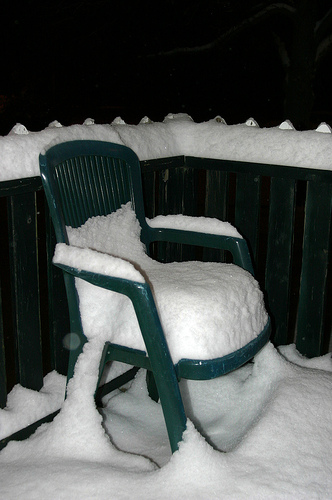<image>
Can you confirm if the snow is on the chair? Yes. Looking at the image, I can see the snow is positioned on top of the chair, with the chair providing support. Is the chair in front of the snow? No. The chair is not in front of the snow. The spatial positioning shows a different relationship between these objects. 